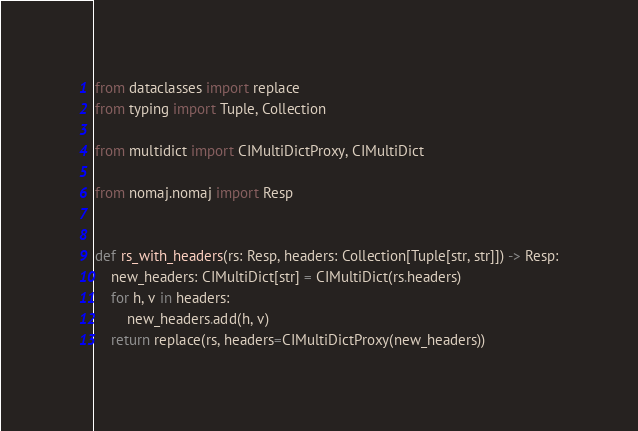<code> <loc_0><loc_0><loc_500><loc_500><_Python_>from dataclasses import replace
from typing import Tuple, Collection

from multidict import CIMultiDictProxy, CIMultiDict

from nomaj.nomaj import Resp


def rs_with_headers(rs: Resp, headers: Collection[Tuple[str, str]]) -> Resp:
    new_headers: CIMultiDict[str] = CIMultiDict(rs.headers)
    for h, v in headers:
        new_headers.add(h, v)
    return replace(rs, headers=CIMultiDictProxy(new_headers))
</code> 